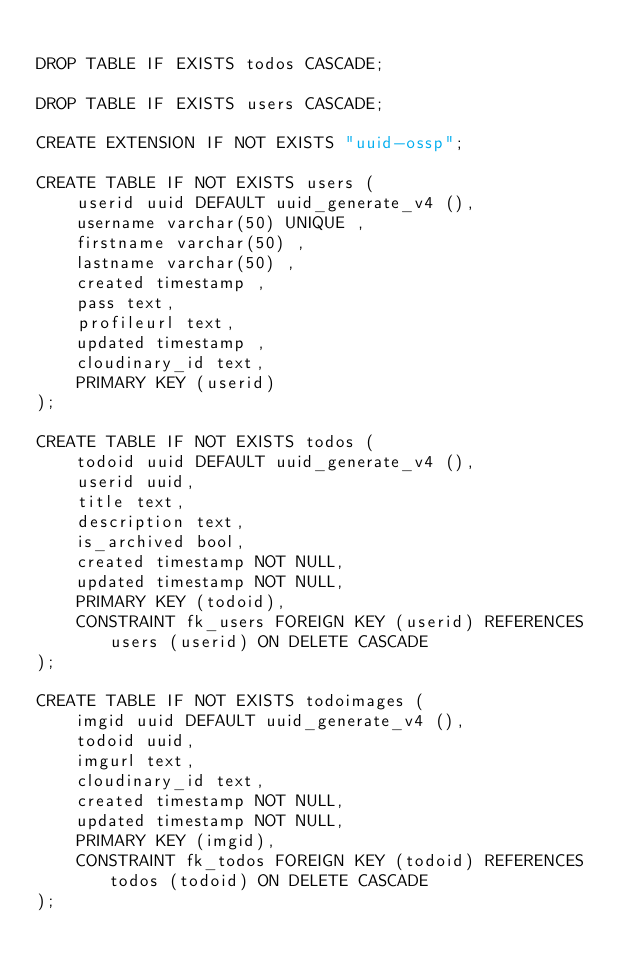Convert code to text. <code><loc_0><loc_0><loc_500><loc_500><_SQL_>
DROP TABLE IF EXISTS todos CASCADE;

DROP TABLE IF EXISTS users CASCADE;

CREATE EXTENSION IF NOT EXISTS "uuid-ossp";

CREATE TABLE IF NOT EXISTS users (
    userid uuid DEFAULT uuid_generate_v4 (),
    username varchar(50) UNIQUE ,
    firstname varchar(50) ,
    lastname varchar(50) ,
    created timestamp ,
    pass text,
    profileurl text,
    updated timestamp ,
    cloudinary_id text,
    PRIMARY KEY (userid)
);

CREATE TABLE IF NOT EXISTS todos (
    todoid uuid DEFAULT uuid_generate_v4 (),
    userid uuid,
    title text,
    description text,
    is_archived bool,
    created timestamp NOT NULL,
    updated timestamp NOT NULL,
    PRIMARY KEY (todoid),
    CONSTRAINT fk_users FOREIGN KEY (userid) REFERENCES users (userid) ON DELETE CASCADE
);

CREATE TABLE IF NOT EXISTS todoimages (
    imgid uuid DEFAULT uuid_generate_v4 (),
    todoid uuid,
    imgurl text,
    cloudinary_id text,
    created timestamp NOT NULL,
    updated timestamp NOT NULL,
    PRIMARY KEY (imgid),
    CONSTRAINT fk_todos FOREIGN KEY (todoid) REFERENCES todos (todoid) ON DELETE CASCADE
);</code> 